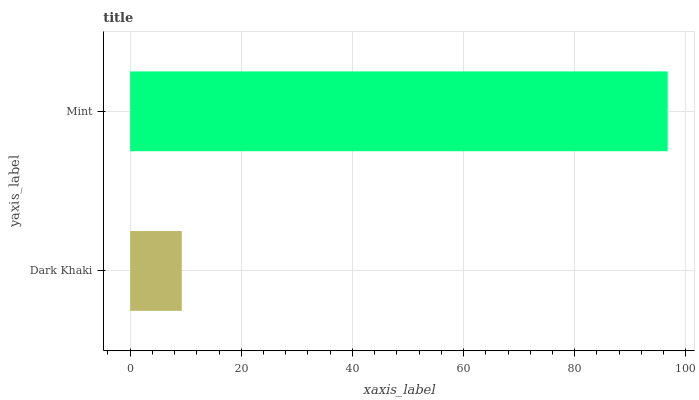Is Dark Khaki the minimum?
Answer yes or no. Yes. Is Mint the maximum?
Answer yes or no. Yes. Is Mint the minimum?
Answer yes or no. No. Is Mint greater than Dark Khaki?
Answer yes or no. Yes. Is Dark Khaki less than Mint?
Answer yes or no. Yes. Is Dark Khaki greater than Mint?
Answer yes or no. No. Is Mint less than Dark Khaki?
Answer yes or no. No. Is Mint the high median?
Answer yes or no. Yes. Is Dark Khaki the low median?
Answer yes or no. Yes. Is Dark Khaki the high median?
Answer yes or no. No. Is Mint the low median?
Answer yes or no. No. 